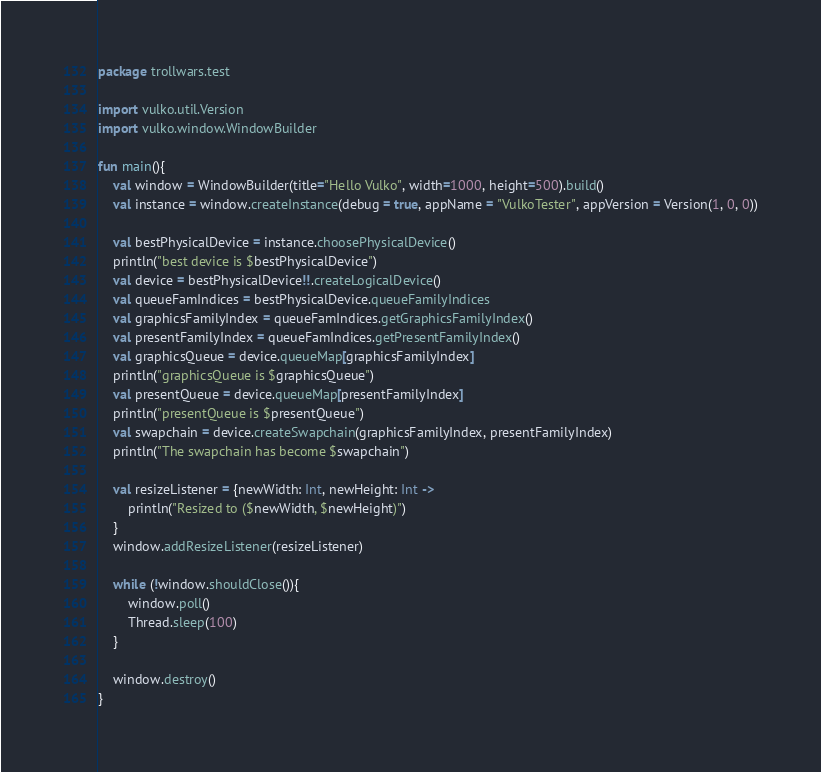Convert code to text. <code><loc_0><loc_0><loc_500><loc_500><_Kotlin_>package trollwars.test

import vulko.util.Version
import vulko.window.WindowBuilder

fun main(){
    val window = WindowBuilder(title="Hello Vulko", width=1000, height=500).build()
    val instance = window.createInstance(debug = true, appName = "VulkoTester", appVersion = Version(1, 0, 0))

    val bestPhysicalDevice = instance.choosePhysicalDevice()
    println("best device is $bestPhysicalDevice")
    val device = bestPhysicalDevice!!.createLogicalDevice()
    val queueFamIndices = bestPhysicalDevice.queueFamilyIndices
    val graphicsFamilyIndex = queueFamIndices.getGraphicsFamilyIndex()
    val presentFamilyIndex = queueFamIndices.getPresentFamilyIndex()
    val graphicsQueue = device.queueMap[graphicsFamilyIndex]
    println("graphicsQueue is $graphicsQueue")
    val presentQueue = device.queueMap[presentFamilyIndex]
    println("presentQueue is $presentQueue")
    val swapchain = device.createSwapchain(graphicsFamilyIndex, presentFamilyIndex)
    println("The swapchain has become $swapchain")

    val resizeListener = {newWidth: Int, newHeight: Int ->
        println("Resized to ($newWidth, $newHeight)")
    }
    window.addResizeListener(resizeListener)

    while (!window.shouldClose()){
        window.poll()
        Thread.sleep(100)
    }

    window.destroy()
}</code> 